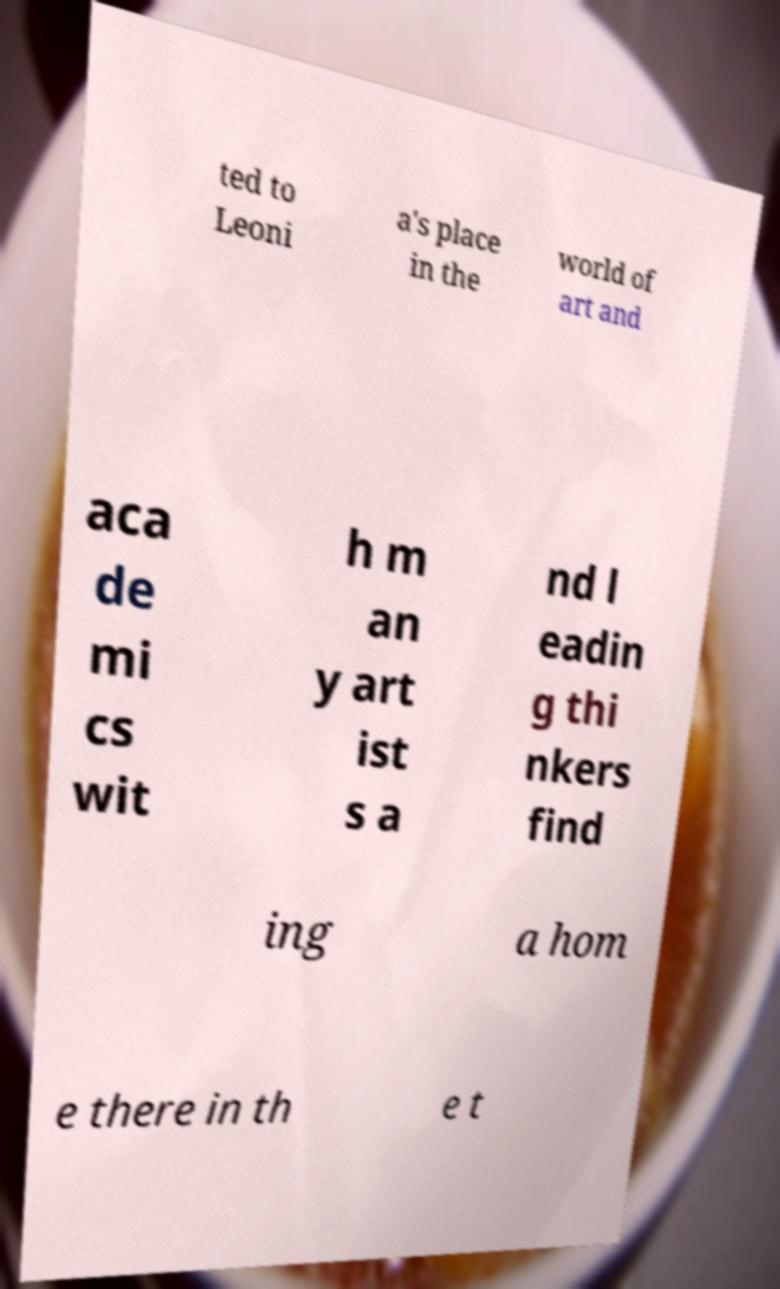Can you read and provide the text displayed in the image?This photo seems to have some interesting text. Can you extract and type it out for me? ted to Leoni a's place in the world of art and aca de mi cs wit h m an y art ist s a nd l eadin g thi nkers find ing a hom e there in th e t 